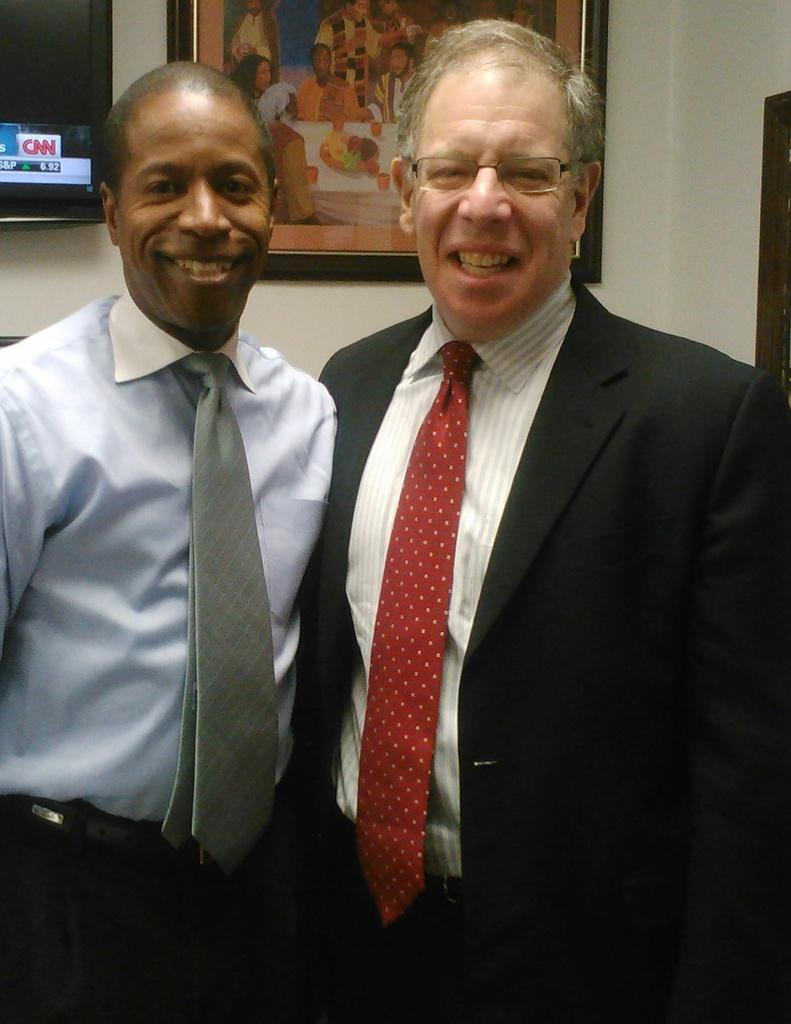How many people are present in the image? There are two people standing in the image. What can be seen in the background of the image? There is a photo frame and a wall in the background of the image. Is there a masked person in the image? No, there is no masked person present in the image. Is it raining in the image? There is no indication of rain in the image. 